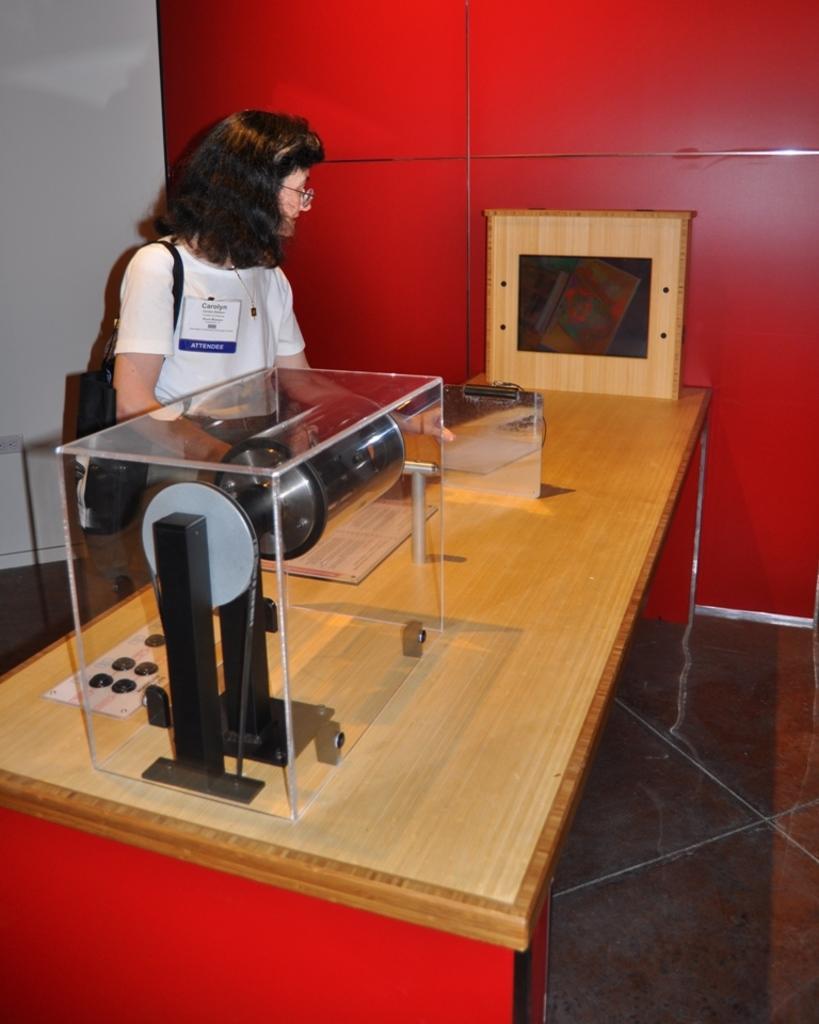Please provide a concise description of this image. She is standing. She is wearing a bag. There is a table. There is a machine on a table. 